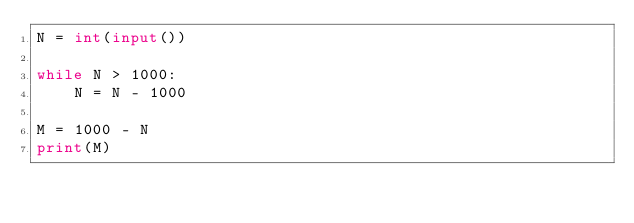Convert code to text. <code><loc_0><loc_0><loc_500><loc_500><_Python_>N = int(input())

while N > 1000:
    N = N - 1000

M = 1000 - N
print(M)
</code> 